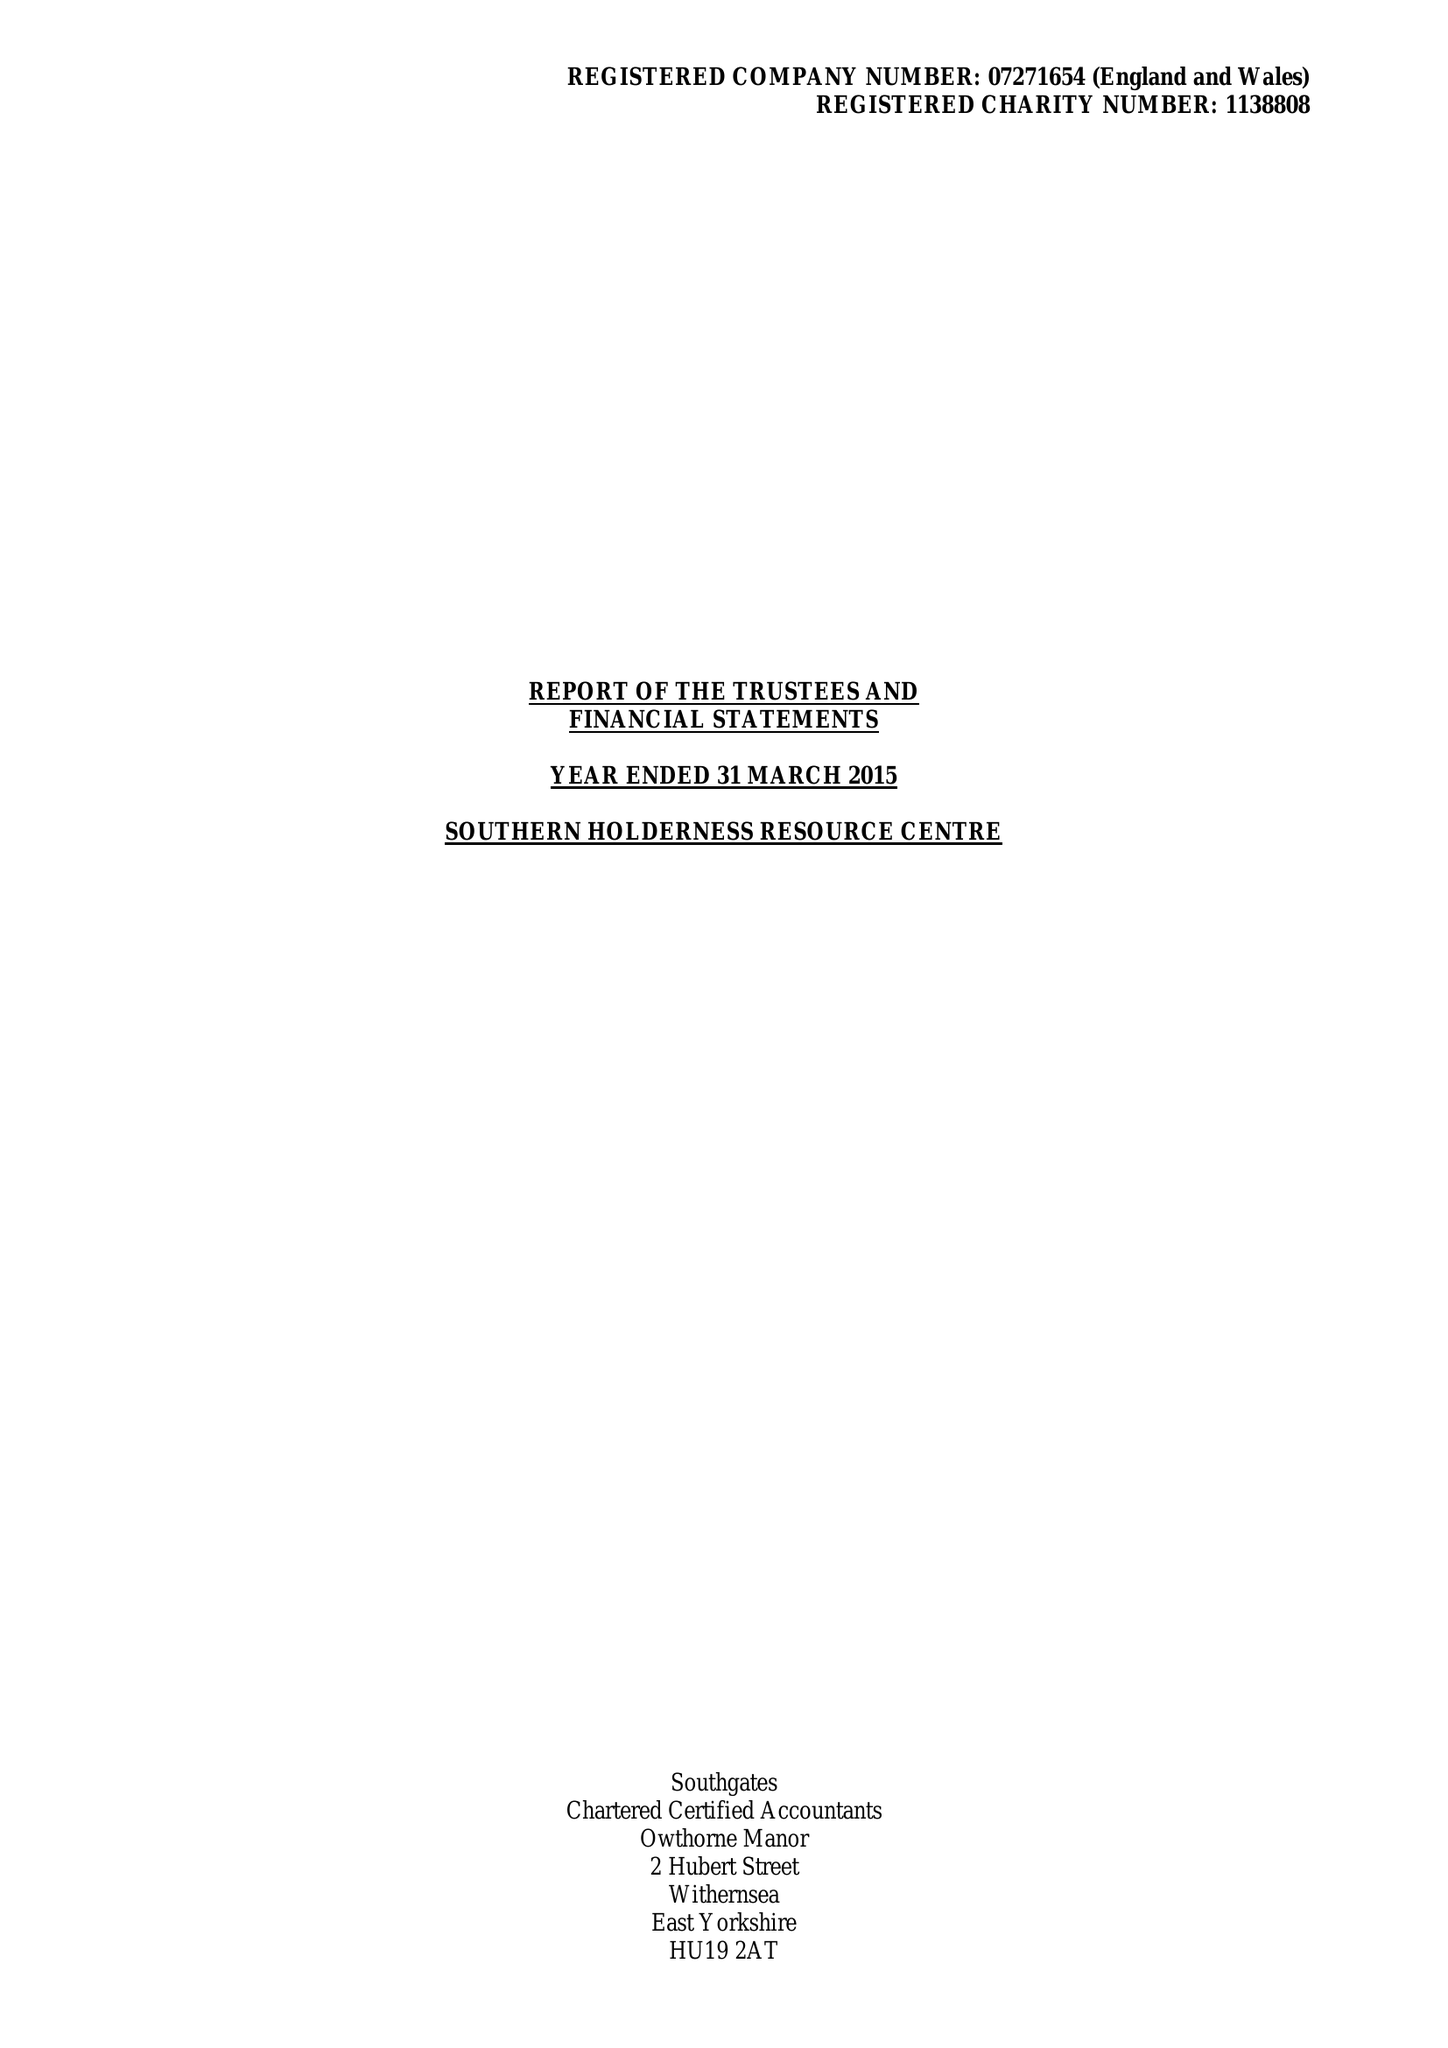What is the value for the address__post_town?
Answer the question using a single word or phrase. WITHERNSEA 